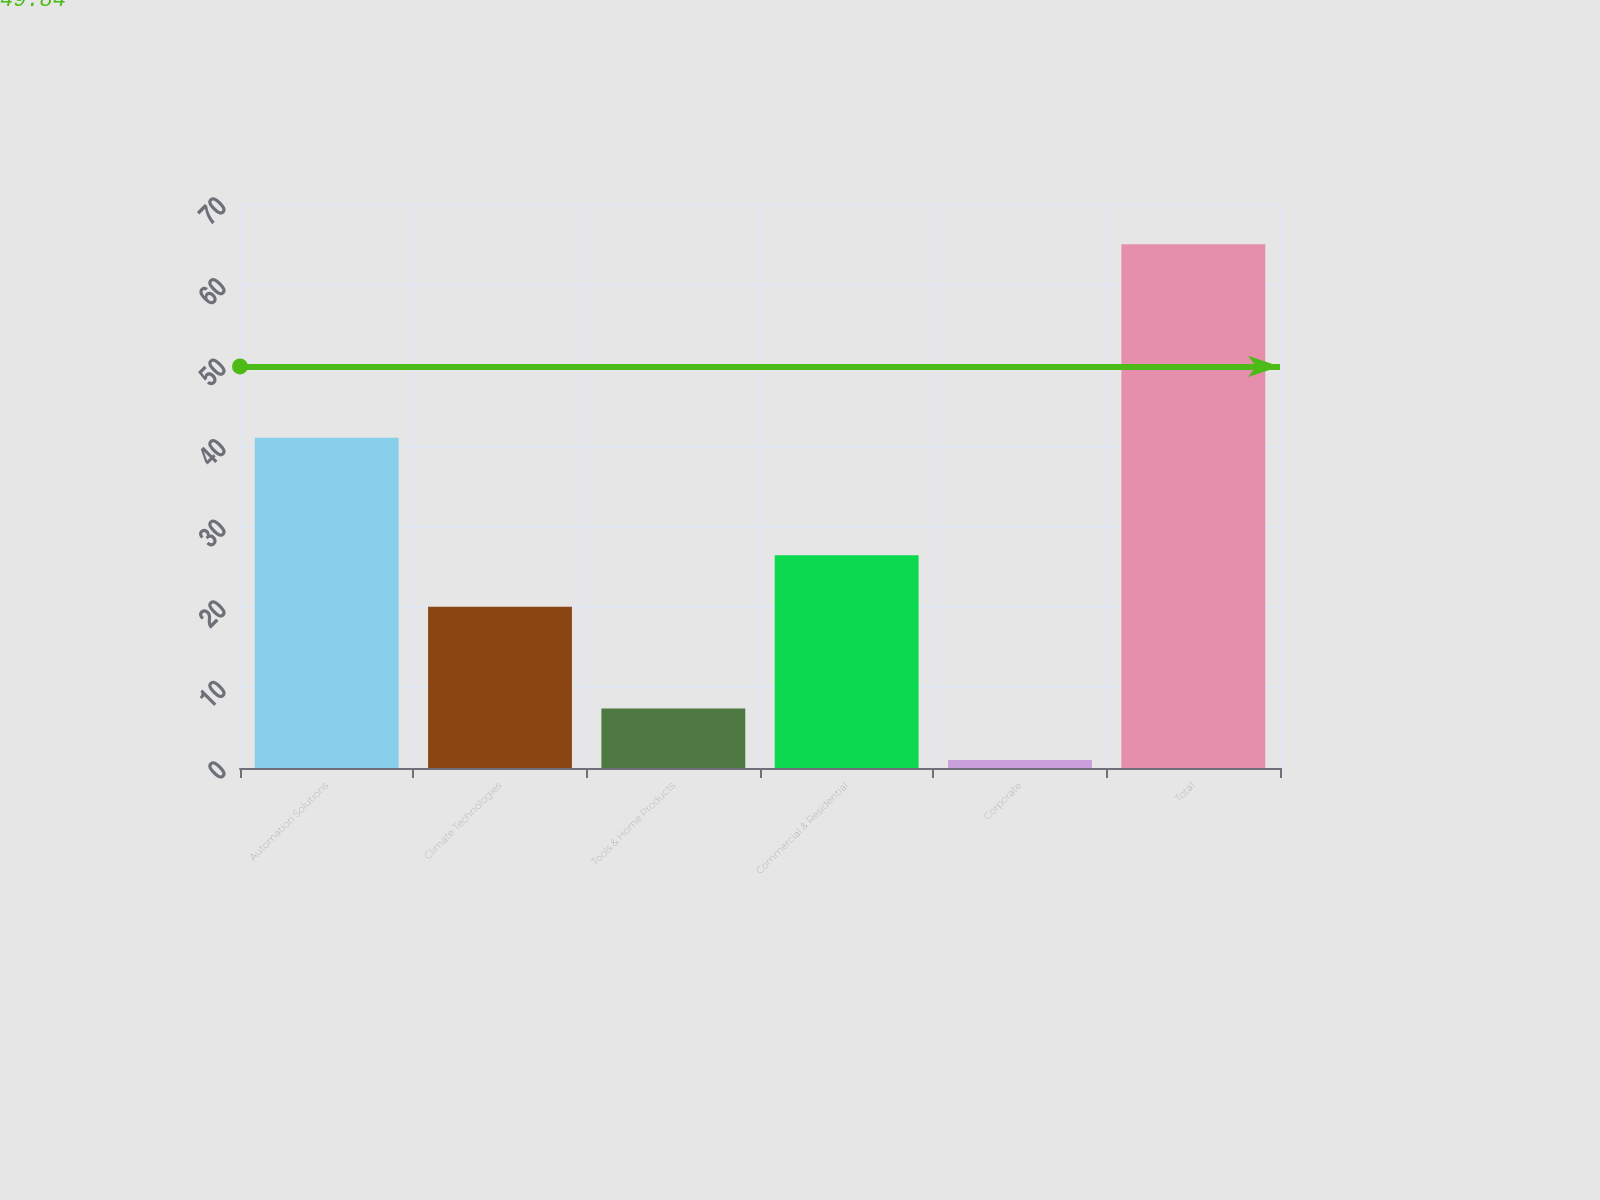<chart> <loc_0><loc_0><loc_500><loc_500><bar_chart><fcel>Automation Solutions<fcel>Climate Technologies<fcel>Tools & Home Products<fcel>Commercial & Residential<fcel>Corporate<fcel>Total<nl><fcel>41<fcel>20<fcel>7.4<fcel>26.4<fcel>1<fcel>65<nl></chart> 